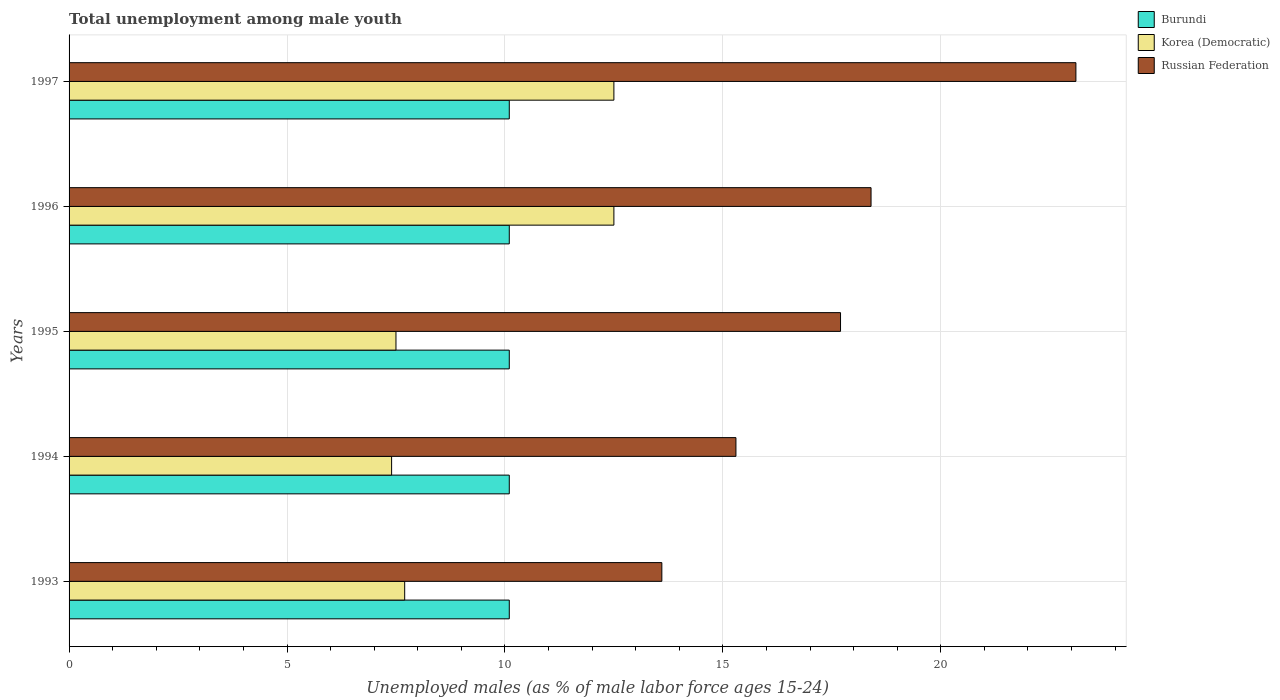How many different coloured bars are there?
Keep it short and to the point. 3. How many bars are there on the 5th tick from the bottom?
Offer a terse response. 3. What is the label of the 3rd group of bars from the top?
Make the answer very short. 1995. What is the percentage of unemployed males in in Russian Federation in 1997?
Ensure brevity in your answer.  23.1. Across all years, what is the minimum percentage of unemployed males in in Burundi?
Your response must be concise. 10.1. In which year was the percentage of unemployed males in in Burundi maximum?
Make the answer very short. 1993. In which year was the percentage of unemployed males in in Russian Federation minimum?
Provide a short and direct response. 1993. What is the total percentage of unemployed males in in Russian Federation in the graph?
Give a very brief answer. 88.1. What is the difference between the percentage of unemployed males in in Russian Federation in 1993 and that in 1997?
Provide a succinct answer. -9.5. What is the difference between the percentage of unemployed males in in Korea (Democratic) in 1993 and the percentage of unemployed males in in Russian Federation in 1997?
Give a very brief answer. -15.4. What is the average percentage of unemployed males in in Burundi per year?
Provide a succinct answer. 10.1. In the year 1997, what is the difference between the percentage of unemployed males in in Korea (Democratic) and percentage of unemployed males in in Burundi?
Your answer should be very brief. 2.4. In how many years, is the percentage of unemployed males in in Korea (Democratic) greater than 2 %?
Ensure brevity in your answer.  5. What is the ratio of the percentage of unemployed males in in Korea (Democratic) in 1993 to that in 1996?
Make the answer very short. 0.62. Is the percentage of unemployed males in in Burundi in 1994 less than that in 1997?
Your response must be concise. No. Is the difference between the percentage of unemployed males in in Korea (Democratic) in 1994 and 1997 greater than the difference between the percentage of unemployed males in in Burundi in 1994 and 1997?
Offer a very short reply. No. What is the difference between the highest and the lowest percentage of unemployed males in in Burundi?
Your answer should be compact. 0. In how many years, is the percentage of unemployed males in in Korea (Democratic) greater than the average percentage of unemployed males in in Korea (Democratic) taken over all years?
Offer a very short reply. 2. Is the sum of the percentage of unemployed males in in Korea (Democratic) in 1993 and 1995 greater than the maximum percentage of unemployed males in in Burundi across all years?
Make the answer very short. Yes. What does the 2nd bar from the top in 1997 represents?
Provide a short and direct response. Korea (Democratic). What does the 2nd bar from the bottom in 1995 represents?
Offer a terse response. Korea (Democratic). Does the graph contain any zero values?
Offer a terse response. No. Does the graph contain grids?
Your answer should be compact. Yes. Where does the legend appear in the graph?
Your answer should be very brief. Top right. What is the title of the graph?
Your response must be concise. Total unemployment among male youth. Does "Romania" appear as one of the legend labels in the graph?
Your answer should be very brief. No. What is the label or title of the X-axis?
Your answer should be very brief. Unemployed males (as % of male labor force ages 15-24). What is the label or title of the Y-axis?
Keep it short and to the point. Years. What is the Unemployed males (as % of male labor force ages 15-24) of Burundi in 1993?
Make the answer very short. 10.1. What is the Unemployed males (as % of male labor force ages 15-24) of Korea (Democratic) in 1993?
Your answer should be compact. 7.7. What is the Unemployed males (as % of male labor force ages 15-24) of Russian Federation in 1993?
Make the answer very short. 13.6. What is the Unemployed males (as % of male labor force ages 15-24) of Burundi in 1994?
Your answer should be compact. 10.1. What is the Unemployed males (as % of male labor force ages 15-24) in Korea (Democratic) in 1994?
Offer a very short reply. 7.4. What is the Unemployed males (as % of male labor force ages 15-24) in Russian Federation in 1994?
Keep it short and to the point. 15.3. What is the Unemployed males (as % of male labor force ages 15-24) in Burundi in 1995?
Your answer should be very brief. 10.1. What is the Unemployed males (as % of male labor force ages 15-24) in Korea (Democratic) in 1995?
Keep it short and to the point. 7.5. What is the Unemployed males (as % of male labor force ages 15-24) of Russian Federation in 1995?
Provide a succinct answer. 17.7. What is the Unemployed males (as % of male labor force ages 15-24) of Burundi in 1996?
Your response must be concise. 10.1. What is the Unemployed males (as % of male labor force ages 15-24) in Korea (Democratic) in 1996?
Provide a short and direct response. 12.5. What is the Unemployed males (as % of male labor force ages 15-24) of Russian Federation in 1996?
Provide a short and direct response. 18.4. What is the Unemployed males (as % of male labor force ages 15-24) in Burundi in 1997?
Ensure brevity in your answer.  10.1. What is the Unemployed males (as % of male labor force ages 15-24) of Korea (Democratic) in 1997?
Offer a terse response. 12.5. What is the Unemployed males (as % of male labor force ages 15-24) in Russian Federation in 1997?
Ensure brevity in your answer.  23.1. Across all years, what is the maximum Unemployed males (as % of male labor force ages 15-24) of Burundi?
Keep it short and to the point. 10.1. Across all years, what is the maximum Unemployed males (as % of male labor force ages 15-24) of Korea (Democratic)?
Give a very brief answer. 12.5. Across all years, what is the maximum Unemployed males (as % of male labor force ages 15-24) of Russian Federation?
Your answer should be very brief. 23.1. Across all years, what is the minimum Unemployed males (as % of male labor force ages 15-24) of Burundi?
Provide a short and direct response. 10.1. Across all years, what is the minimum Unemployed males (as % of male labor force ages 15-24) of Korea (Democratic)?
Ensure brevity in your answer.  7.4. Across all years, what is the minimum Unemployed males (as % of male labor force ages 15-24) of Russian Federation?
Your response must be concise. 13.6. What is the total Unemployed males (as % of male labor force ages 15-24) in Burundi in the graph?
Your answer should be very brief. 50.5. What is the total Unemployed males (as % of male labor force ages 15-24) of Korea (Democratic) in the graph?
Provide a short and direct response. 47.6. What is the total Unemployed males (as % of male labor force ages 15-24) of Russian Federation in the graph?
Provide a succinct answer. 88.1. What is the difference between the Unemployed males (as % of male labor force ages 15-24) of Russian Federation in 1993 and that in 1994?
Your answer should be compact. -1.7. What is the difference between the Unemployed males (as % of male labor force ages 15-24) of Korea (Democratic) in 1993 and that in 1995?
Provide a short and direct response. 0.2. What is the difference between the Unemployed males (as % of male labor force ages 15-24) in Korea (Democratic) in 1993 and that in 1997?
Make the answer very short. -4.8. What is the difference between the Unemployed males (as % of male labor force ages 15-24) in Russian Federation in 1993 and that in 1997?
Provide a succinct answer. -9.5. What is the difference between the Unemployed males (as % of male labor force ages 15-24) of Korea (Democratic) in 1994 and that in 1995?
Offer a terse response. -0.1. What is the difference between the Unemployed males (as % of male labor force ages 15-24) of Russian Federation in 1994 and that in 1996?
Provide a short and direct response. -3.1. What is the difference between the Unemployed males (as % of male labor force ages 15-24) of Korea (Democratic) in 1994 and that in 1997?
Provide a succinct answer. -5.1. What is the difference between the Unemployed males (as % of male labor force ages 15-24) of Burundi in 1995 and that in 1997?
Your response must be concise. 0. What is the difference between the Unemployed males (as % of male labor force ages 15-24) of Korea (Democratic) in 1995 and that in 1997?
Ensure brevity in your answer.  -5. What is the difference between the Unemployed males (as % of male labor force ages 15-24) of Russian Federation in 1995 and that in 1997?
Your response must be concise. -5.4. What is the difference between the Unemployed males (as % of male labor force ages 15-24) of Korea (Democratic) in 1993 and the Unemployed males (as % of male labor force ages 15-24) of Russian Federation in 1994?
Your response must be concise. -7.6. What is the difference between the Unemployed males (as % of male labor force ages 15-24) in Burundi in 1993 and the Unemployed males (as % of male labor force ages 15-24) in Russian Federation in 1995?
Offer a very short reply. -7.6. What is the difference between the Unemployed males (as % of male labor force ages 15-24) in Korea (Democratic) in 1993 and the Unemployed males (as % of male labor force ages 15-24) in Russian Federation in 1995?
Offer a terse response. -10. What is the difference between the Unemployed males (as % of male labor force ages 15-24) of Burundi in 1993 and the Unemployed males (as % of male labor force ages 15-24) of Korea (Democratic) in 1996?
Give a very brief answer. -2.4. What is the difference between the Unemployed males (as % of male labor force ages 15-24) of Burundi in 1993 and the Unemployed males (as % of male labor force ages 15-24) of Russian Federation in 1996?
Your answer should be compact. -8.3. What is the difference between the Unemployed males (as % of male labor force ages 15-24) of Korea (Democratic) in 1993 and the Unemployed males (as % of male labor force ages 15-24) of Russian Federation in 1997?
Give a very brief answer. -15.4. What is the difference between the Unemployed males (as % of male labor force ages 15-24) of Burundi in 1994 and the Unemployed males (as % of male labor force ages 15-24) of Korea (Democratic) in 1995?
Provide a short and direct response. 2.6. What is the difference between the Unemployed males (as % of male labor force ages 15-24) of Burundi in 1994 and the Unemployed males (as % of male labor force ages 15-24) of Korea (Democratic) in 1997?
Offer a terse response. -2.4. What is the difference between the Unemployed males (as % of male labor force ages 15-24) of Korea (Democratic) in 1994 and the Unemployed males (as % of male labor force ages 15-24) of Russian Federation in 1997?
Your response must be concise. -15.7. What is the difference between the Unemployed males (as % of male labor force ages 15-24) in Burundi in 1995 and the Unemployed males (as % of male labor force ages 15-24) in Korea (Democratic) in 1996?
Ensure brevity in your answer.  -2.4. What is the difference between the Unemployed males (as % of male labor force ages 15-24) of Burundi in 1995 and the Unemployed males (as % of male labor force ages 15-24) of Russian Federation in 1996?
Offer a terse response. -8.3. What is the difference between the Unemployed males (as % of male labor force ages 15-24) in Korea (Democratic) in 1995 and the Unemployed males (as % of male labor force ages 15-24) in Russian Federation in 1996?
Ensure brevity in your answer.  -10.9. What is the difference between the Unemployed males (as % of male labor force ages 15-24) in Burundi in 1995 and the Unemployed males (as % of male labor force ages 15-24) in Korea (Democratic) in 1997?
Make the answer very short. -2.4. What is the difference between the Unemployed males (as % of male labor force ages 15-24) of Burundi in 1995 and the Unemployed males (as % of male labor force ages 15-24) of Russian Federation in 1997?
Your response must be concise. -13. What is the difference between the Unemployed males (as % of male labor force ages 15-24) of Korea (Democratic) in 1995 and the Unemployed males (as % of male labor force ages 15-24) of Russian Federation in 1997?
Give a very brief answer. -15.6. What is the difference between the Unemployed males (as % of male labor force ages 15-24) of Burundi in 1996 and the Unemployed males (as % of male labor force ages 15-24) of Korea (Democratic) in 1997?
Your answer should be compact. -2.4. What is the average Unemployed males (as % of male labor force ages 15-24) in Burundi per year?
Provide a short and direct response. 10.1. What is the average Unemployed males (as % of male labor force ages 15-24) of Korea (Democratic) per year?
Your answer should be compact. 9.52. What is the average Unemployed males (as % of male labor force ages 15-24) of Russian Federation per year?
Give a very brief answer. 17.62. In the year 1994, what is the difference between the Unemployed males (as % of male labor force ages 15-24) of Burundi and Unemployed males (as % of male labor force ages 15-24) of Korea (Democratic)?
Provide a short and direct response. 2.7. In the year 1994, what is the difference between the Unemployed males (as % of male labor force ages 15-24) of Burundi and Unemployed males (as % of male labor force ages 15-24) of Russian Federation?
Give a very brief answer. -5.2. In the year 1995, what is the difference between the Unemployed males (as % of male labor force ages 15-24) of Burundi and Unemployed males (as % of male labor force ages 15-24) of Korea (Democratic)?
Offer a very short reply. 2.6. In the year 1995, what is the difference between the Unemployed males (as % of male labor force ages 15-24) in Korea (Democratic) and Unemployed males (as % of male labor force ages 15-24) in Russian Federation?
Offer a very short reply. -10.2. In the year 1996, what is the difference between the Unemployed males (as % of male labor force ages 15-24) of Burundi and Unemployed males (as % of male labor force ages 15-24) of Korea (Democratic)?
Give a very brief answer. -2.4. In the year 1996, what is the difference between the Unemployed males (as % of male labor force ages 15-24) in Korea (Democratic) and Unemployed males (as % of male labor force ages 15-24) in Russian Federation?
Make the answer very short. -5.9. In the year 1997, what is the difference between the Unemployed males (as % of male labor force ages 15-24) in Burundi and Unemployed males (as % of male labor force ages 15-24) in Korea (Democratic)?
Your answer should be very brief. -2.4. In the year 1997, what is the difference between the Unemployed males (as % of male labor force ages 15-24) in Korea (Democratic) and Unemployed males (as % of male labor force ages 15-24) in Russian Federation?
Keep it short and to the point. -10.6. What is the ratio of the Unemployed males (as % of male labor force ages 15-24) of Korea (Democratic) in 1993 to that in 1994?
Keep it short and to the point. 1.04. What is the ratio of the Unemployed males (as % of male labor force ages 15-24) of Korea (Democratic) in 1993 to that in 1995?
Ensure brevity in your answer.  1.03. What is the ratio of the Unemployed males (as % of male labor force ages 15-24) in Russian Federation in 1993 to that in 1995?
Your answer should be compact. 0.77. What is the ratio of the Unemployed males (as % of male labor force ages 15-24) in Korea (Democratic) in 1993 to that in 1996?
Offer a very short reply. 0.62. What is the ratio of the Unemployed males (as % of male labor force ages 15-24) in Russian Federation in 1993 to that in 1996?
Your answer should be compact. 0.74. What is the ratio of the Unemployed males (as % of male labor force ages 15-24) of Burundi in 1993 to that in 1997?
Give a very brief answer. 1. What is the ratio of the Unemployed males (as % of male labor force ages 15-24) in Korea (Democratic) in 1993 to that in 1997?
Your response must be concise. 0.62. What is the ratio of the Unemployed males (as % of male labor force ages 15-24) in Russian Federation in 1993 to that in 1997?
Your answer should be compact. 0.59. What is the ratio of the Unemployed males (as % of male labor force ages 15-24) in Korea (Democratic) in 1994 to that in 1995?
Provide a succinct answer. 0.99. What is the ratio of the Unemployed males (as % of male labor force ages 15-24) of Russian Federation in 1994 to that in 1995?
Provide a short and direct response. 0.86. What is the ratio of the Unemployed males (as % of male labor force ages 15-24) in Korea (Democratic) in 1994 to that in 1996?
Provide a short and direct response. 0.59. What is the ratio of the Unemployed males (as % of male labor force ages 15-24) of Russian Federation in 1994 to that in 1996?
Your response must be concise. 0.83. What is the ratio of the Unemployed males (as % of male labor force ages 15-24) in Burundi in 1994 to that in 1997?
Ensure brevity in your answer.  1. What is the ratio of the Unemployed males (as % of male labor force ages 15-24) in Korea (Democratic) in 1994 to that in 1997?
Offer a very short reply. 0.59. What is the ratio of the Unemployed males (as % of male labor force ages 15-24) of Russian Federation in 1994 to that in 1997?
Make the answer very short. 0.66. What is the ratio of the Unemployed males (as % of male labor force ages 15-24) in Korea (Democratic) in 1995 to that in 1996?
Your response must be concise. 0.6. What is the ratio of the Unemployed males (as % of male labor force ages 15-24) in Russian Federation in 1995 to that in 1997?
Keep it short and to the point. 0.77. What is the ratio of the Unemployed males (as % of male labor force ages 15-24) of Korea (Democratic) in 1996 to that in 1997?
Your answer should be very brief. 1. What is the ratio of the Unemployed males (as % of male labor force ages 15-24) of Russian Federation in 1996 to that in 1997?
Provide a succinct answer. 0.8. What is the difference between the highest and the second highest Unemployed males (as % of male labor force ages 15-24) in Korea (Democratic)?
Keep it short and to the point. 0. What is the difference between the highest and the second highest Unemployed males (as % of male labor force ages 15-24) in Russian Federation?
Make the answer very short. 4.7. What is the difference between the highest and the lowest Unemployed males (as % of male labor force ages 15-24) in Russian Federation?
Offer a terse response. 9.5. 